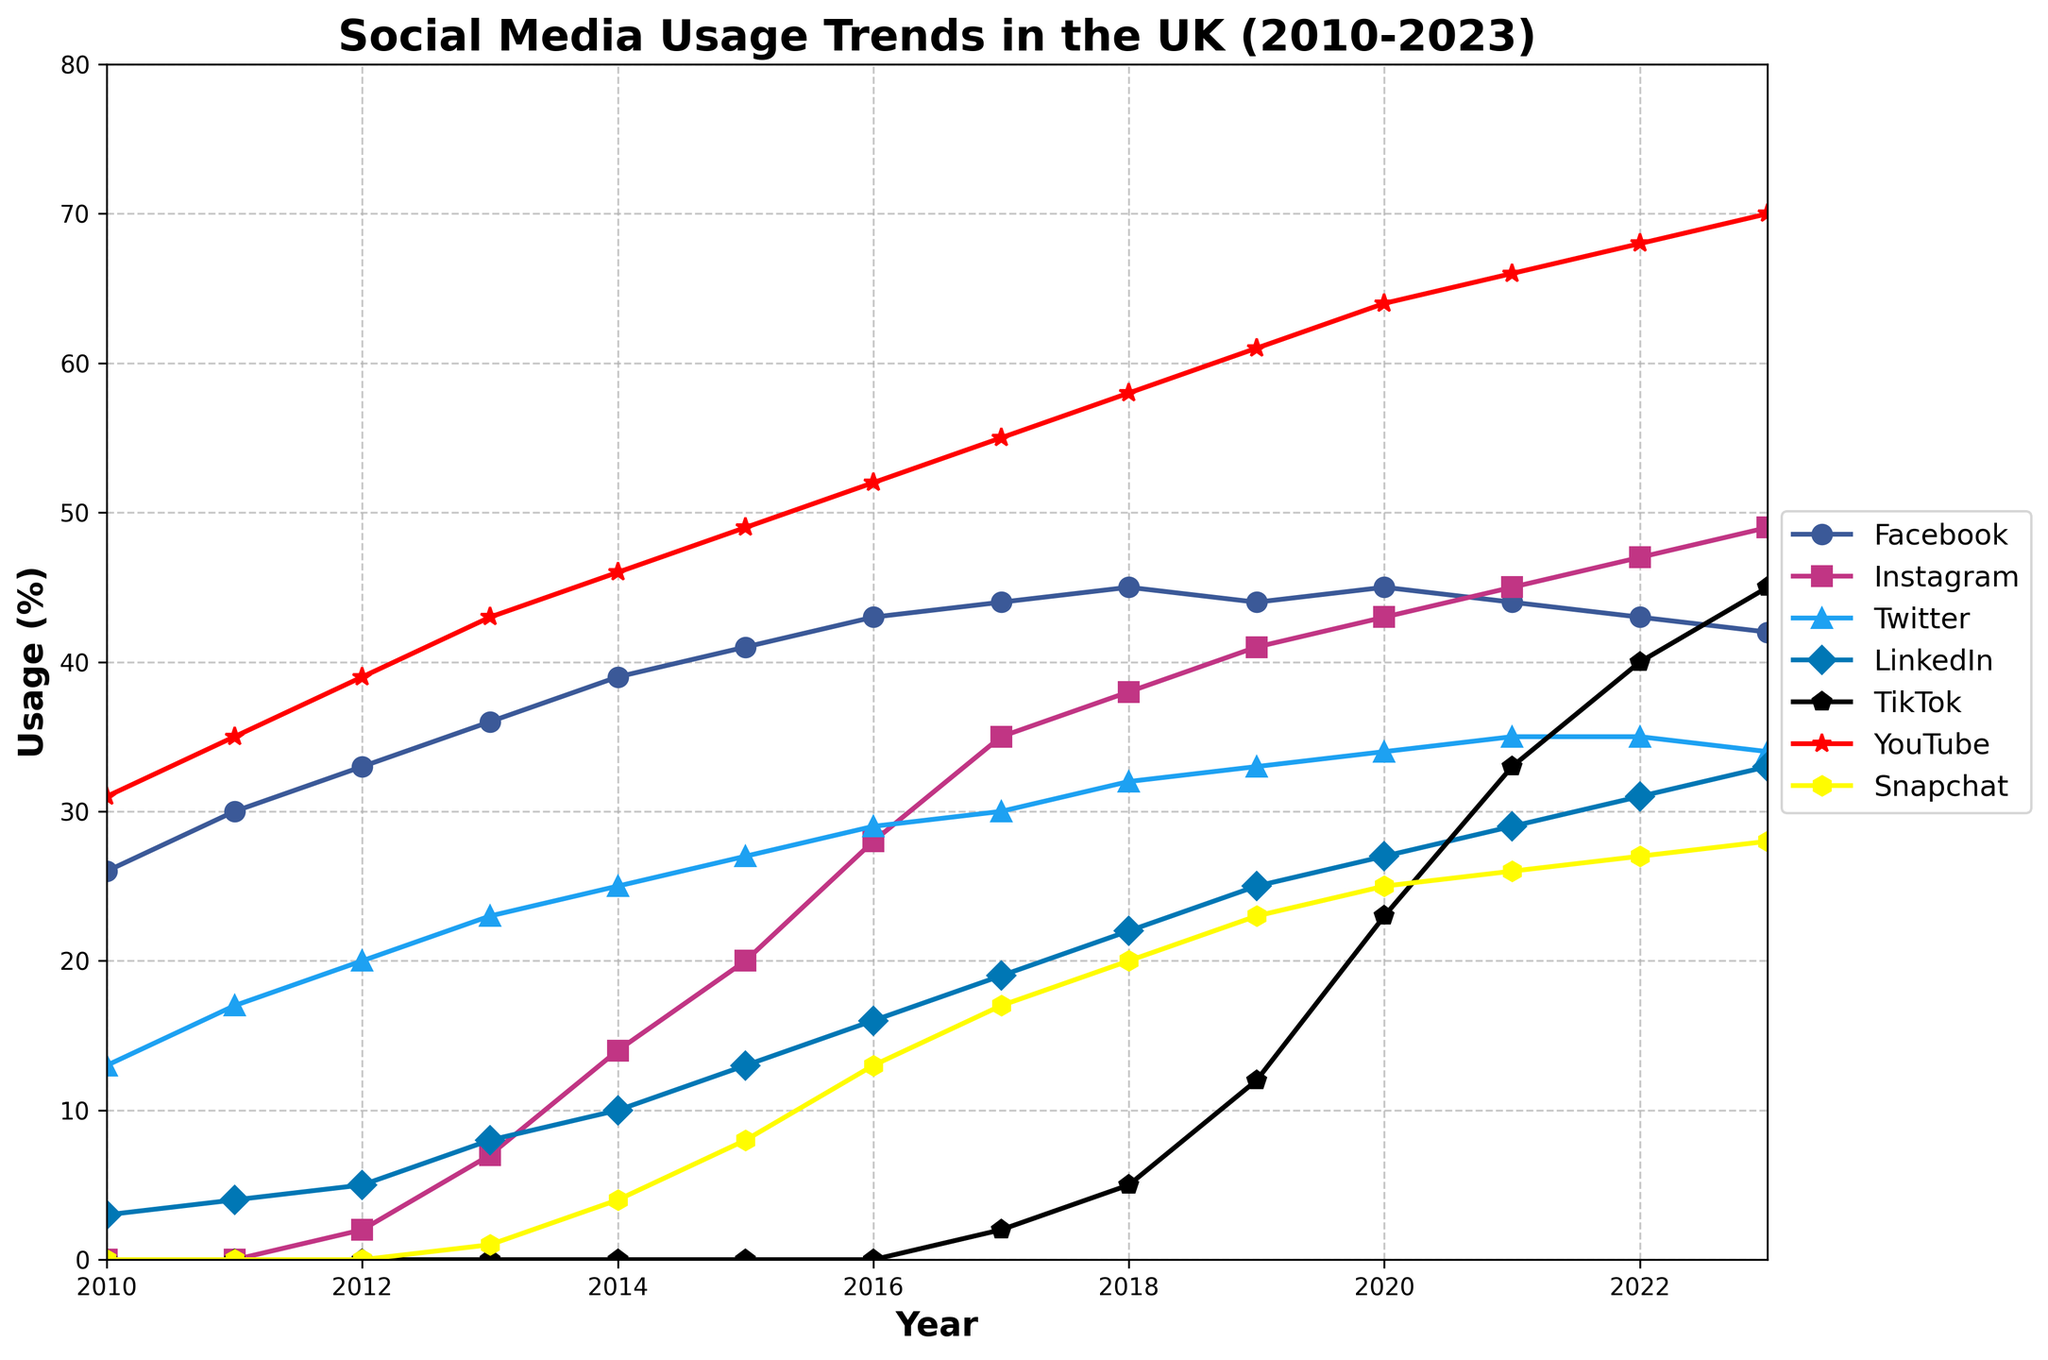What year did TikTok start gaining notable usage in the UK? TikTok appears to begin gaining notable usage around 2017 when it shows up in the data with a small user base.
Answer: 2017 Between 2018 and 2023, which social media platform gained the most in usage? To determine this, subtract the 2018 usage from the 2023 usage for each platform: Facebook: 42-45= -3; Instagram: 49-38= 11; Twitter: 34-32= 2; LinkedIn: 33-22= 11; TikTok: 45-5= 40; YouTube: 70-58= 12; Snapchat: 28-20= 8. TikTok has the highest increase.
Answer: TikTok In what year did Instagram surpass Twitter in usage? To see when Instagram surpasses Twitter, look at the intersection: by checking the data trends on the plot, Instagram surpasses Twitter in 2013.
Answer: 2013 Which social media platform has the highest usage in 2023? Check the 2023 data and determine the highest number: Facebook: 42, Instagram: 49, Twitter: 34, LinkedIn: 33, TikTok: 45, YouTube: 70, Snapchat: 28. YouTube is the highest.
Answer: YouTube What was the usage trend for Facebook from 2010 to 2023? Examine the plot for Facebook from 2010 to 2023: It shows an increase until around 2018, then starts to decline slightly towards 2023.
Answer: Increased until 2018, then declined How much did Snapchat's usage increase from its initial appearance to 2023? Snapchat starts appearing in 2013 with 1%, and it grows to 28% by 2023. The increase is 28 - 1 = 27%.
Answer: 27% Which year showed the most significant increase in LinkedIn usage? Check the graph for LinkedIn and identify the year with the highest upward slope. Significant growth occurs between 2012 to 2013.
Answer: 2012 to 2013 What is the average usage of YouTube over the given years? Average is calculated by summing the YouTube usage from 2010 to 2023 and dividing by the number of years: (31+35+39+43+46+49+52+55+58+61+64+66+68+70)/14 = 53.36%
Answer: 53.36% Is there any platform that shows a consistent growth trend from 2010 to 2023 without any decline? Examine all platforms: Instagram shows consistent growth throughout the entire period, without any declines.
Answer: Instagram How does LinkedIn's usage in 2023 compare to its usage in 2010? LinkedIn usage in 2010 is 3% and in 2023 is 33%. Comparison: 33% - 3% = 30% increase.
Answer: 30% increase 